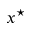<formula> <loc_0><loc_0><loc_500><loc_500>x ^ { ^ { * } }</formula> 